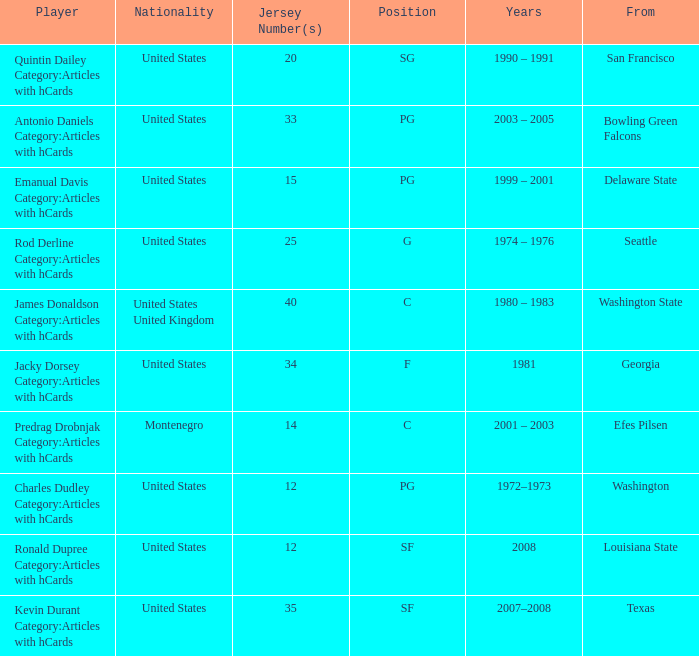What years did the united states player with a jersey number 25 who attended delaware state play? 1999 – 2001. 